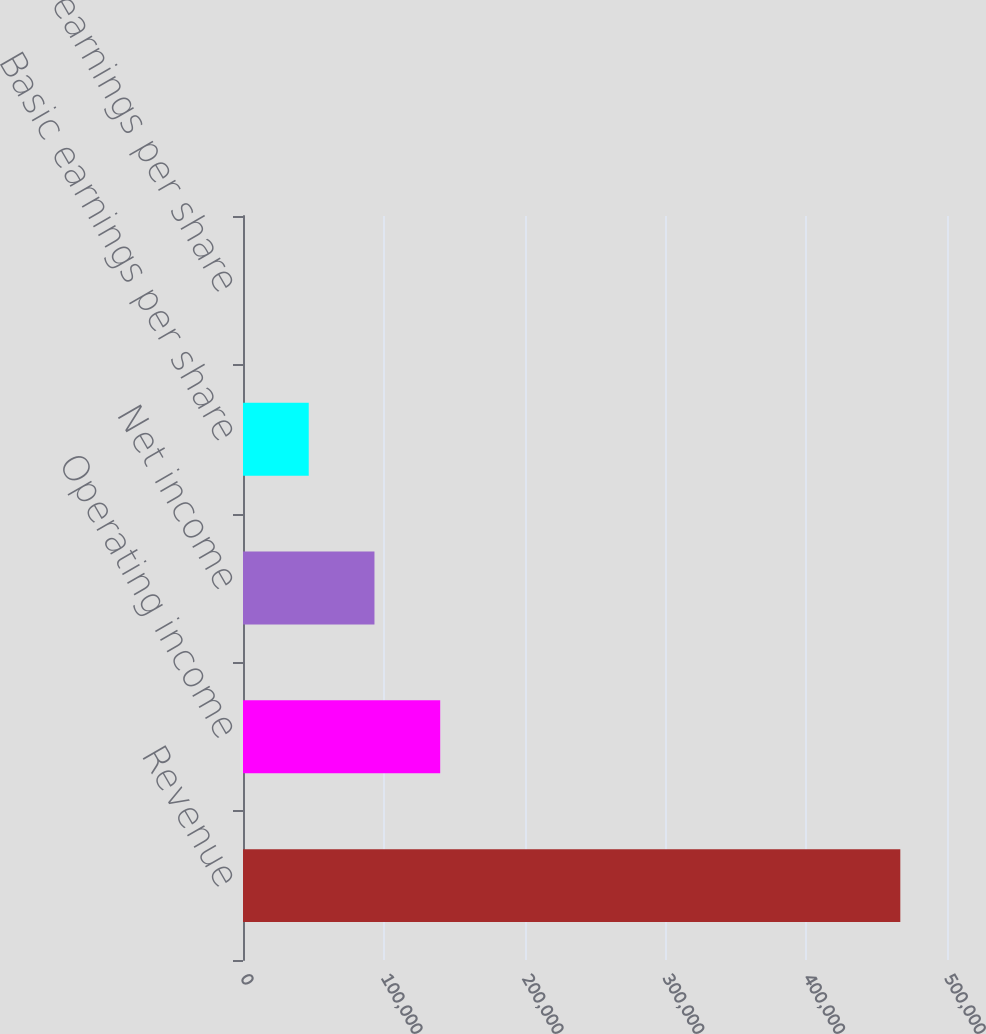<chart> <loc_0><loc_0><loc_500><loc_500><bar_chart><fcel>Revenue<fcel>Operating income<fcel>Net income<fcel>Basic earnings per share<fcel>Diluted earnings per share<nl><fcel>466841<fcel>140053<fcel>93369.4<fcel>46685.4<fcel>1.46<nl></chart> 